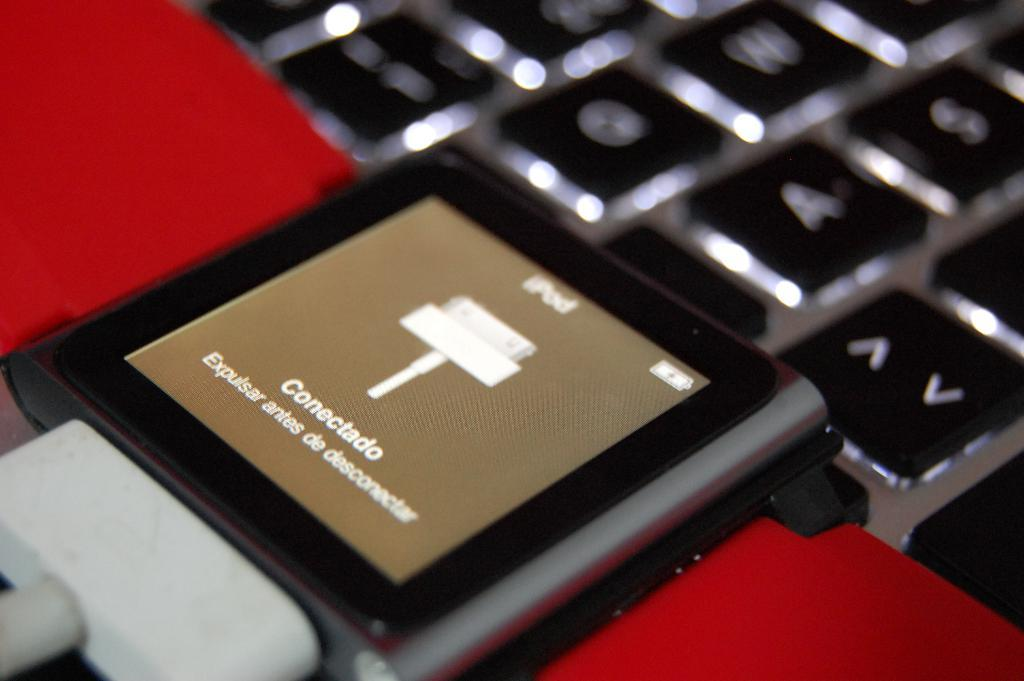<image>
Provide a brief description of the given image. An iPod has Connectado displayed on the screen. 